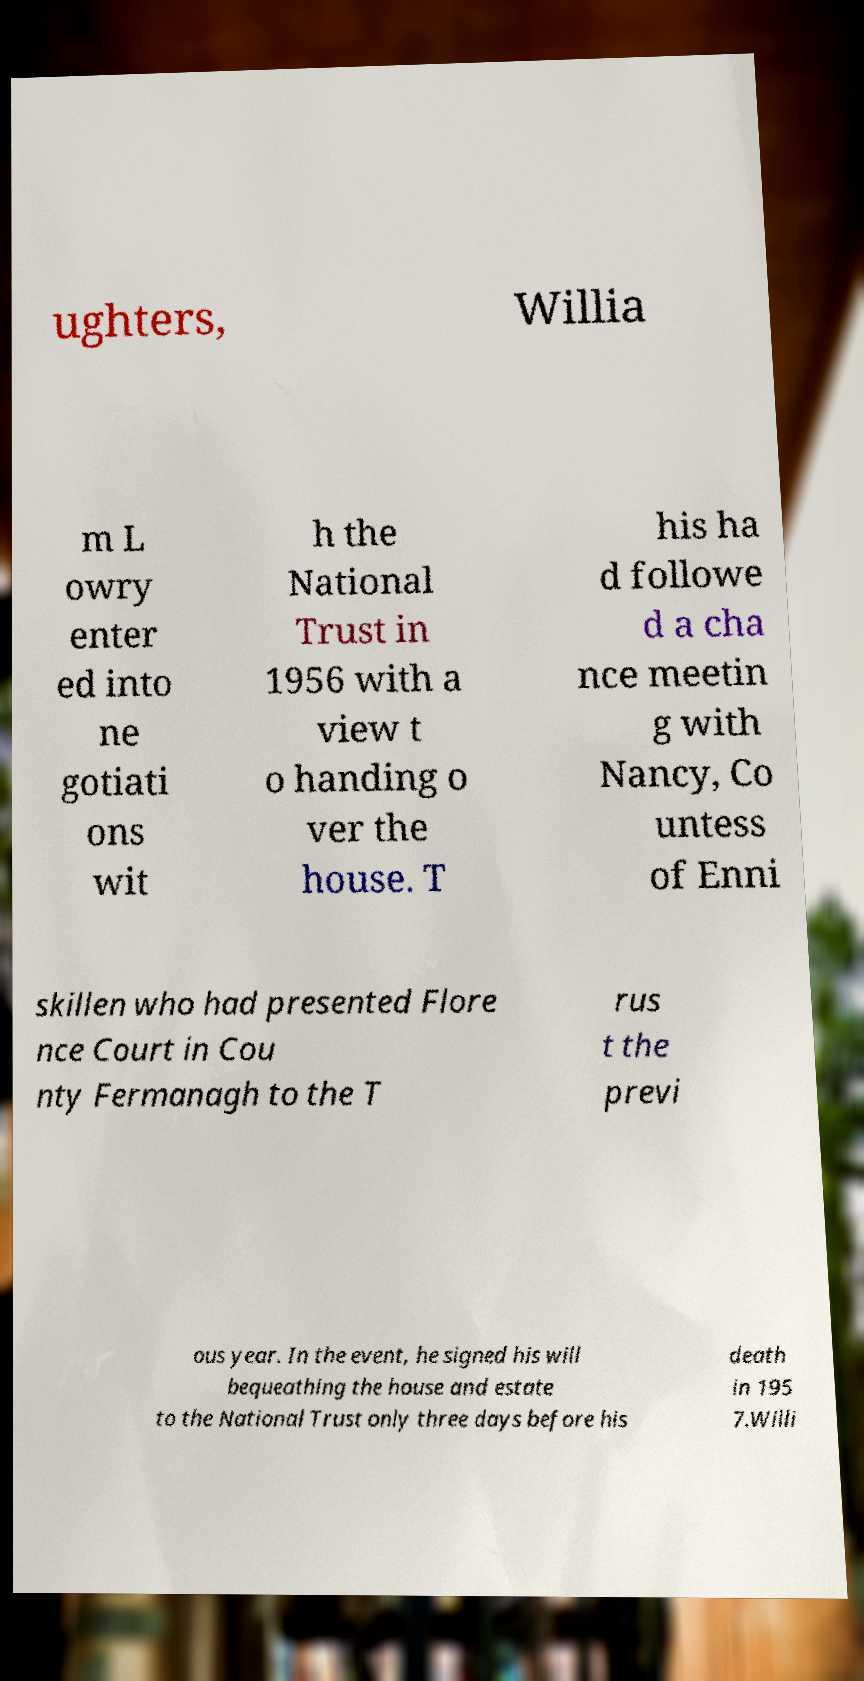Can you accurately transcribe the text from the provided image for me? ughters, Willia m L owry enter ed into ne gotiati ons wit h the National Trust in 1956 with a view t o handing o ver the house. T his ha d followe d a cha nce meetin g with Nancy, Co untess of Enni skillen who had presented Flore nce Court in Cou nty Fermanagh to the T rus t the previ ous year. In the event, he signed his will bequeathing the house and estate to the National Trust only three days before his death in 195 7.Willi 